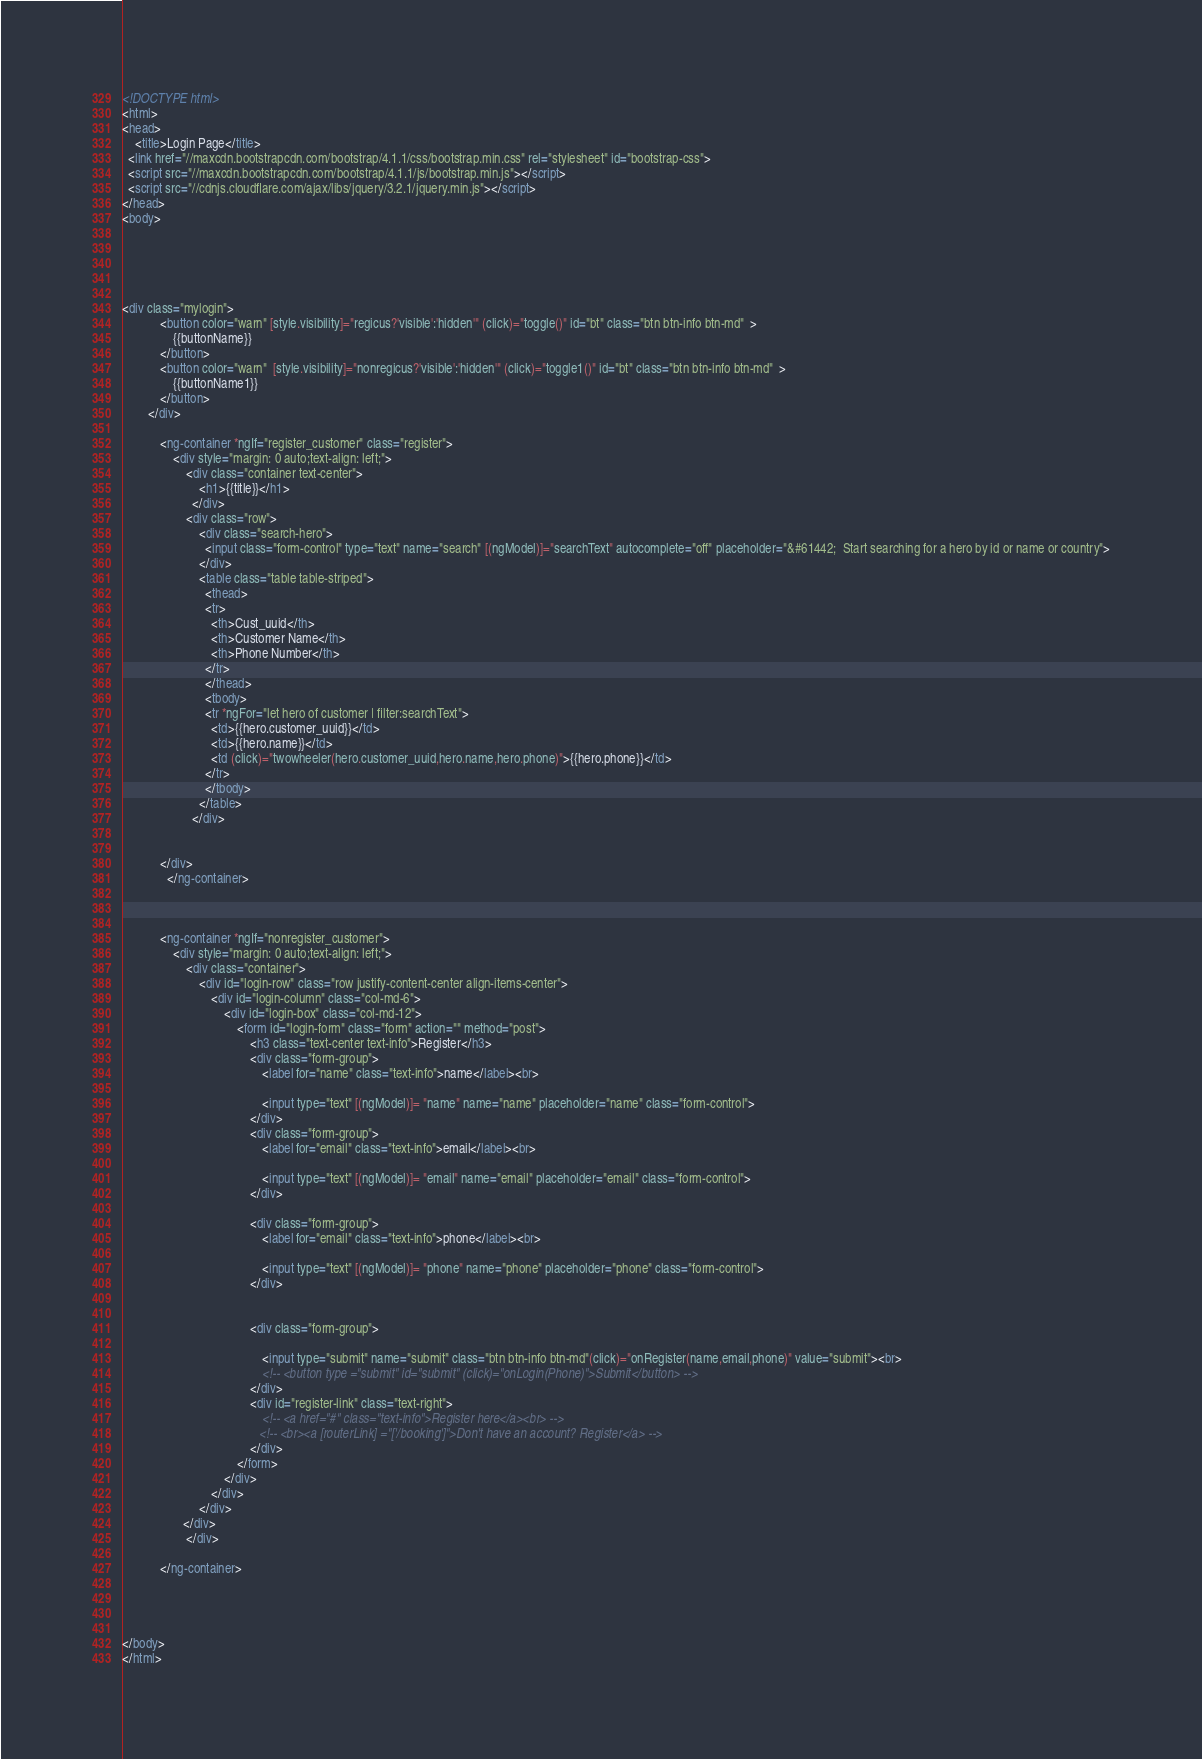<code> <loc_0><loc_0><loc_500><loc_500><_HTML_>
<!DOCTYPE html>
<html>
<head>
	<title>Login Page</title>
  <link href="//maxcdn.bootstrapcdn.com/bootstrap/4.1.1/css/bootstrap.min.css" rel="stylesheet" id="bootstrap-css">
  <script src="//maxcdn.bootstrapcdn.com/bootstrap/4.1.1/js/bootstrap.min.js"></script>
  <script src="//cdnjs.cloudflare.com/ajax/libs/jquery/3.2.1/jquery.min.js"></script>
</head>
<body>
    

 
      

<div class="mylogin">
            <button color="warn" [style.visibility]="regicus?'visible':'hidden'" (click)="toggle()" id="bt" class="btn btn-info btn-md"  >
                {{buttonName}}
            </button>
            <button color="warn"  [style.visibility]="nonregicus?'visible':'hidden'" (click)="toggle1()" id="bt" class="btn btn-info btn-md"  >
                {{buttonName1}}
            </button>
        </div>
            
            <ng-container *ngIf="register_customer" class="register">
                <div style="margin: 0 auto;text-align: left;">
                    <div class="container text-center">
                        <h1>{{title}}</h1>
                      </div>
                    <div class="row">
                        <div class="search-hero">
                          <input class="form-control" type="text" name="search" [(ngModel)]="searchText" autocomplete="off" placeholder="&#61442;  Start searching for a hero by id or name or country">
                        </div>
                        <table class="table table-striped">
                          <thead>
                          <tr>
                            <th>Cust_uuid</th>
                            <th>Customer Name</th>
                            <th>Phone Number</th>
                          </tr>
                          </thead>
                          <tbody>
                          <tr *ngFor="let hero of customer | filter:searchText">
                            <td>{{hero.customer_uuid}}</td>
                            <td>{{hero.name}}</td>
                            <td (click)="twowheeler(hero.customer_uuid,hero.name,hero.phone)">{{hero.phone}}</td>
                          </tr>
                          </tbody>
                        </table>
                      </div>

               
            </div>
              </ng-container>
         

    
            <ng-container *ngIf="nonregister_customer">
                <div style="margin: 0 auto;text-align: left;">
                    <div class="container">
                        <div id="login-row" class="row justify-content-center align-items-center">
                            <div id="login-column" class="col-md-6">
                                <div id="login-box" class="col-md-12">
                                    <form id="login-form" class="form" action="" method="post">
                                        <h3 class="text-center text-info">Register</h3>
                                        <div class="form-group">
                                            <label for="name" class="text-info">name</label><br>
                
                                            <input type="text" [(ngModel)]= "name" name="name" placeholder="name" class="form-control">
                                        </div>
                                        <div class="form-group">
                                            <label for="email" class="text-info">email</label><br>
                
                                            <input type="text" [(ngModel)]= "email" name="email" placeholder="email" class="form-control">
                                        </div>

                                        <div class="form-group">
                                            <label for="email" class="text-info">phone</label><br>
                
                                            <input type="text" [(ngModel)]= "phone" name="phone" placeholder="phone" class="form-control">
                                        </div>
                                    
                                    
                                        <div class="form-group">
                                           
                                            <input type="submit" name="submit" class="btn btn-info btn-md"(click)="onRegister(name,email,phone)" value="submit"><br>
                                            <!-- <button type ="submit" id="submit" (click)="onLogin(Phone)">Submit</button> -->
                                        </div>
                                        <div id="register-link" class="text-right">
                                            <!-- <a href="#" class="text-info">Register here</a><br> -->
                                           <!-- <br><a [routerLink] ="['/booking']">Don't have an account? Register</a> -->
                                        </div>
                                    </form>
                                </div>
                            </div>
                        </div>
                   </div>
                    </div>
              
            </ng-container>
            


 
</body>
</html></code> 